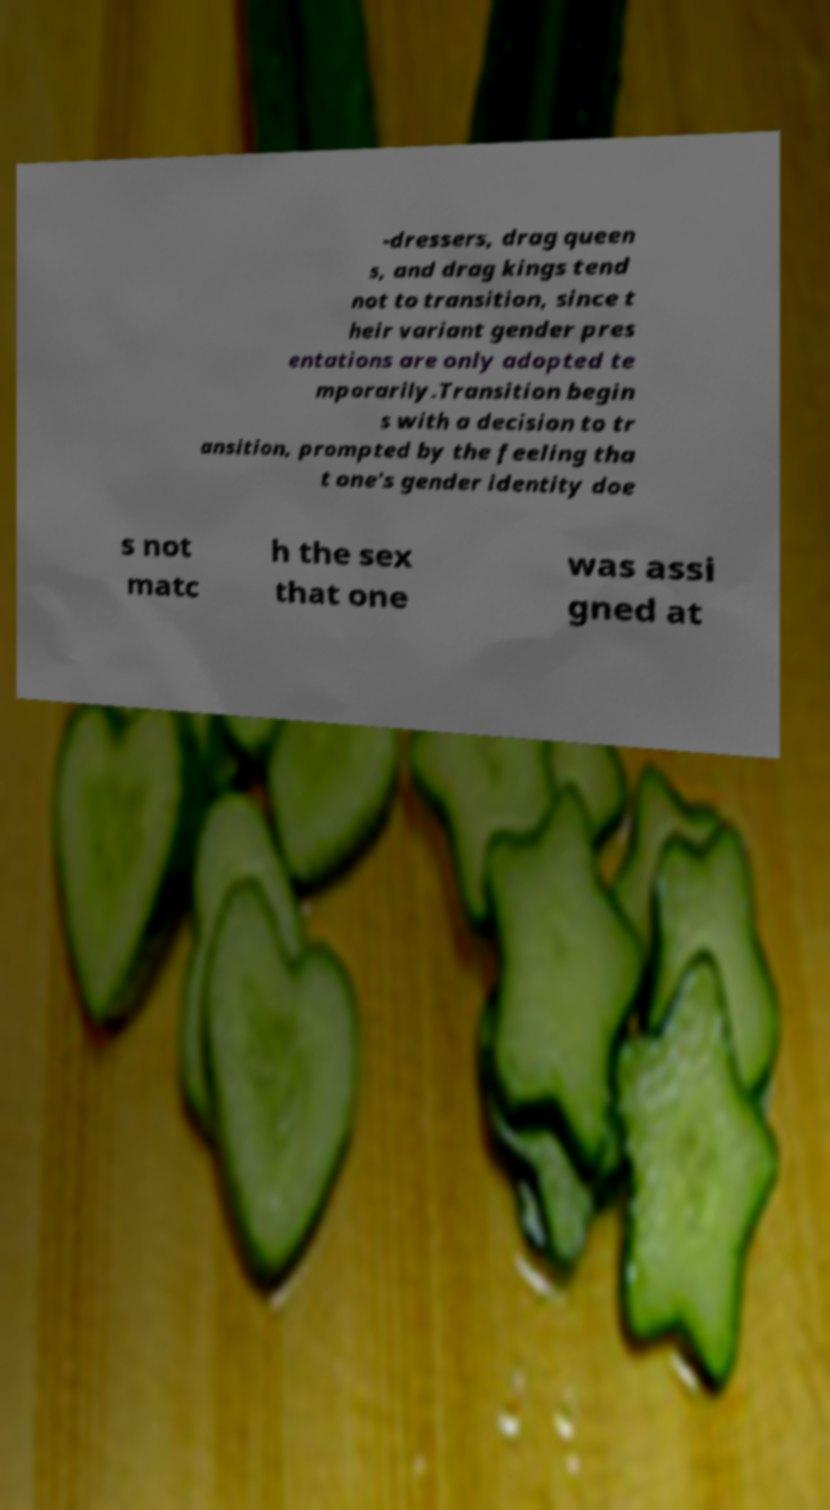Could you assist in decoding the text presented in this image and type it out clearly? -dressers, drag queen s, and drag kings tend not to transition, since t heir variant gender pres entations are only adopted te mporarily.Transition begin s with a decision to tr ansition, prompted by the feeling tha t one's gender identity doe s not matc h the sex that one was assi gned at 